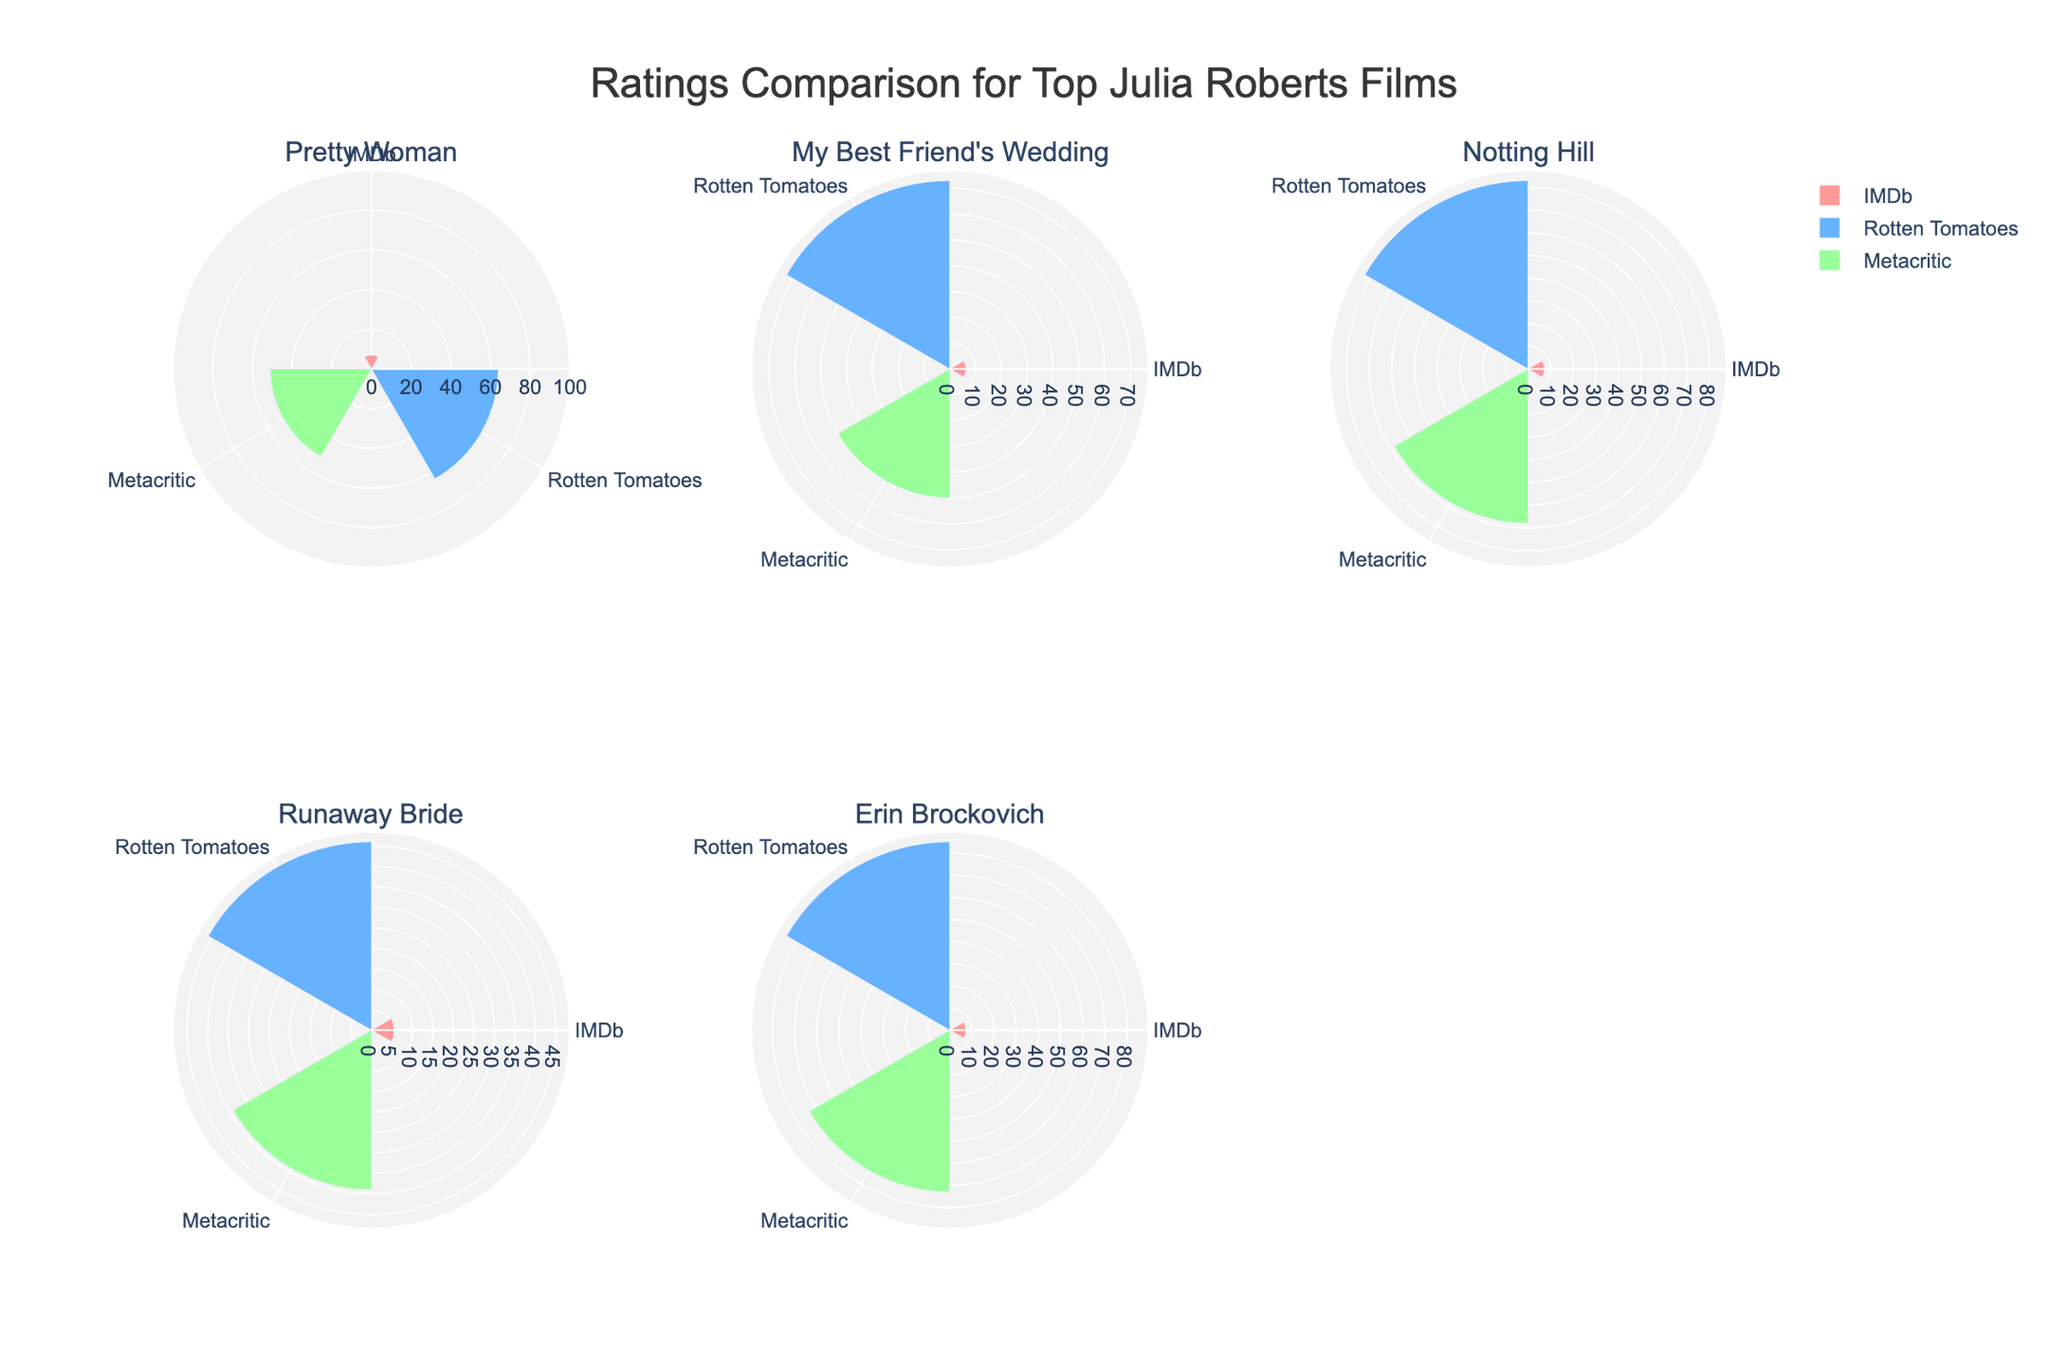Which Julia Roberts movie has the highest IMDb rating? Look at the IMDb ratings for each movie. 'Erin Brockovich' has the highest IMDb rating at 7.3.
Answer: Erin Brockovich Which movie received the lowest Metacritic score? Observe the Metacritic scores for all the movies. 'Runaway Bride' has the lowest score at 39.
Answer: Runaway Bride What are the Rotten Tomatoes ratings for 'Pretty Woman' and 'Notting Hill'? Compare the Rotten Tomatoes ratings for both movies: 'Pretty Woman' has 64% and 'Notting Hill' has 83%.
Answer: Pretty Woman - 64%, Notting Hill - 83% Which movie has the highest rating on Rotten Tomatoes? Look at the Rotten Tomatoes ratings for all the listed movies. 'Erin Brockovich' has the highest rating at 85%.
Answer: Erin Brockovich How many movies have a Metacritic score higher than 50? Check each movie's Metacritic score to see which ones are above 50. 'Notting Hill' and 'Erin Brockovich' have scores higher than 50.
Answer: 2 Do any movies receive the same score from different sources? Observe if any movies have the same rating from different sources. 'My Best Friend's Wedding' received close scores from Rotten Tomatoes (73) and Metacritic (50).
Answer: No exact same rating Which movie has the largest difference between IMDb and Rotten Tomatoes ratings? Calculate the difference between IMDb and Rotten Tomatoes ratings for each movie, and identify the largest one. 'Runaway Bride' has a significant difference: IMDb (5.6) to Rotten Tomatoes (46%).
Answer: Runaway Bride For which movie are the ratings most consistent across all sources? Compare the differences in ratings from IMDb, Rotten Tomatoes, and Metacritic for each movie to find the smallest variance. 'Erin Brockovich' has ratings of 7.3 (IMDb), 85% (Rotten Tomatoes), and 73 (Metacritic), showing the most consistency.
Answer: Erin Brockovich 